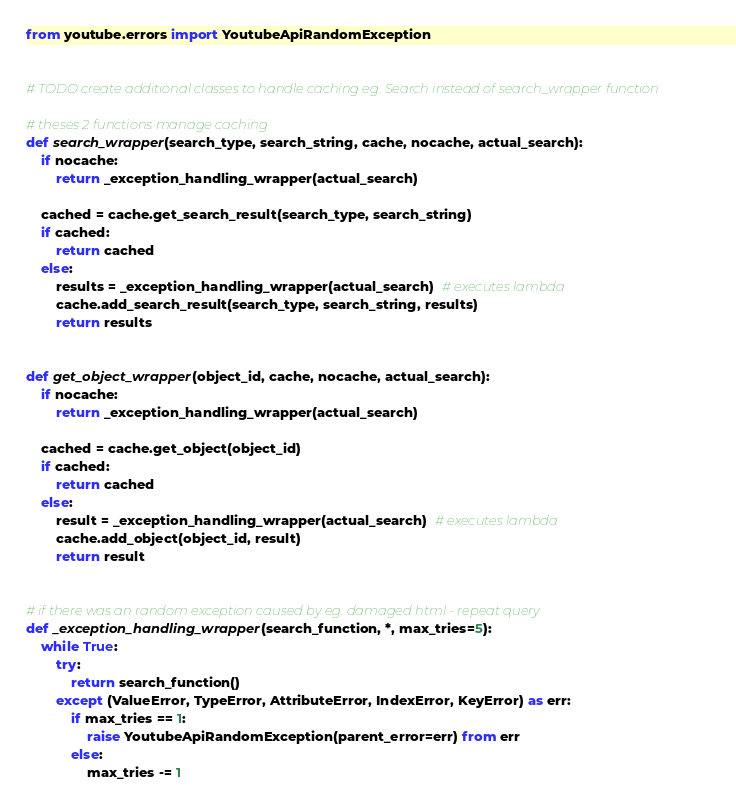Convert code to text. <code><loc_0><loc_0><loc_500><loc_500><_Python_>from youtube.errors import YoutubeApiRandomException


# TODO create additional classes to handle caching eg. Search instead of search_wrapper function

# theses 2 functions manage caching
def search_wrapper(search_type, search_string, cache, nocache, actual_search):
    if nocache:
        return _exception_handling_wrapper(actual_search)

    cached = cache.get_search_result(search_type, search_string)
    if cached:
        return cached
    else:
        results = _exception_handling_wrapper(actual_search)  # executes lambda
        cache.add_search_result(search_type, search_string, results)
        return results


def get_object_wrapper(object_id, cache, nocache, actual_search):
    if nocache:
        return _exception_handling_wrapper(actual_search)

    cached = cache.get_object(object_id)
    if cached:
        return cached
    else:
        result = _exception_handling_wrapper(actual_search)  # executes lambda
        cache.add_object(object_id, result)
        return result


# if there was an random exception caused by eg. damaged html - repeat query
def _exception_handling_wrapper(search_function, *, max_tries=5):
    while True:
        try:
            return search_function()
        except (ValueError, TypeError, AttributeError, IndexError, KeyError) as err:
            if max_tries == 1:
                raise YoutubeApiRandomException(parent_error=err) from err
            else:
                max_tries -= 1
</code> 